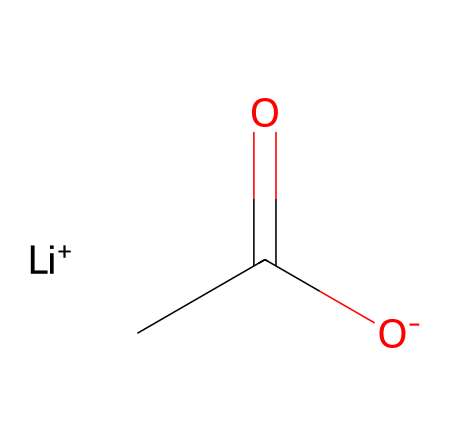How many lithium atoms are present in this chemical? The chemical structure includes [Li+], which explicitly represents one lithium atom. The brackets indicate that this is a specific ion, confirming the presence of a single lithium atom.
Answer: one What type of bond is formed between lithium and oxygen in this structure? The structure shows [O-] and [Li+]. The lithium ion (Li+) has a positive charge, and the oxygen atom has a negative charge, indicating an ionic bond due to the electrostatic attraction between the two oppositely charged ions.
Answer: ionic bond What is the total number of carbon atoms in this chemical? In the chemical structure, there are two carbon atoms present in C(=O)C — one for the carbonyl group (C=O) and one connected to it, confirming that carbon appears twice.
Answer: two What type of ion is represented by [Li+]? The notation [Li+] indicates that lithium is in a +1 oxidation state, characterizing it as a cation. Cations are positively charged ions formed when an atom loses one or more electrons.
Answer: cation Which part of the chemical is responsible for its reactivity in batteries? The carbonyl group (C=O) is likely involved in reactions that store and release energy in batteries. The presence of lithium cation along with the functional groups suggests that this structure can participate in redox reactions, which are crucial in battery chemistry.
Answer: carbonyl group 